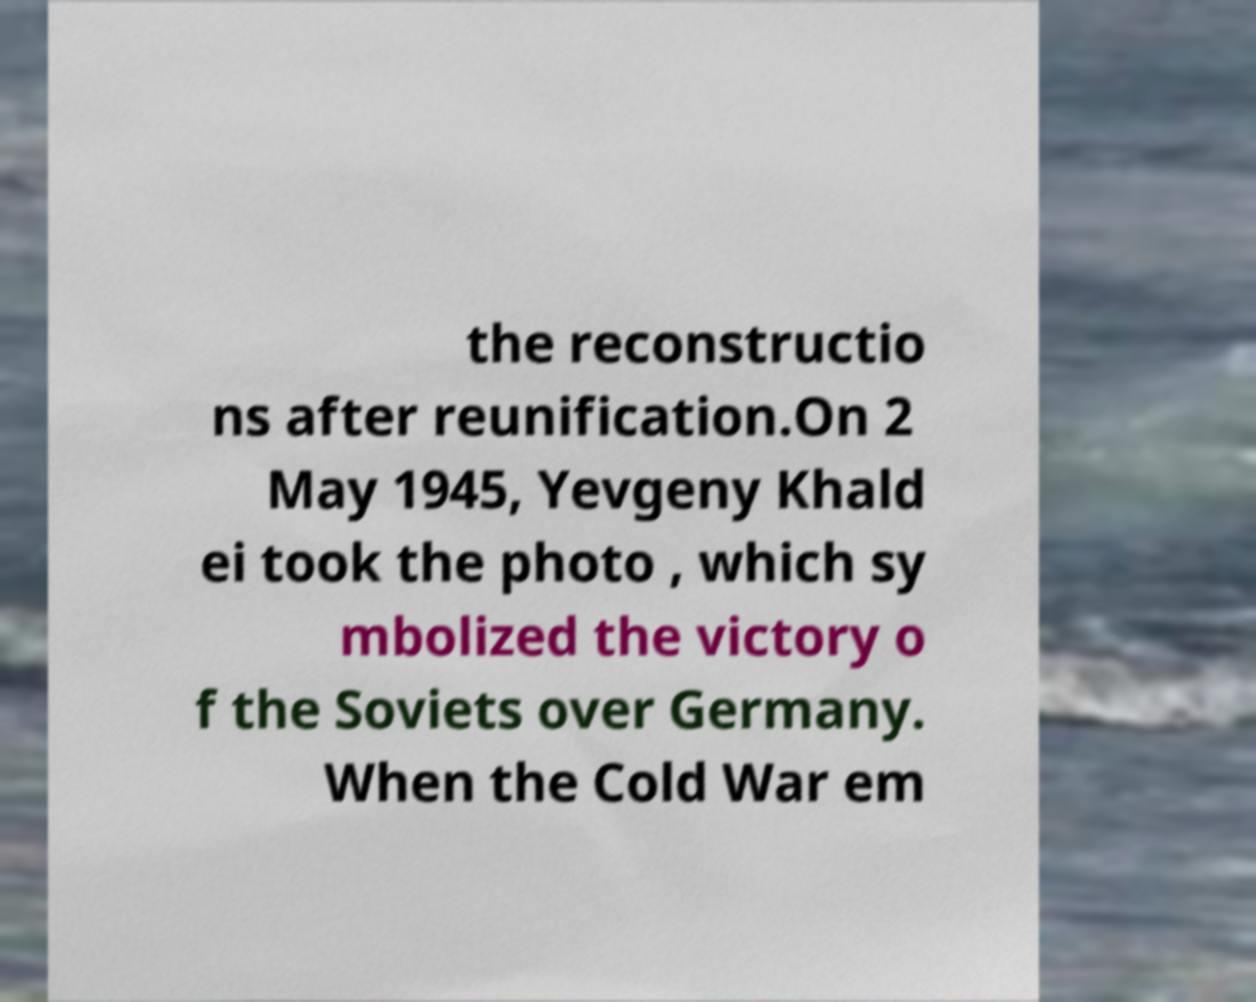There's text embedded in this image that I need extracted. Can you transcribe it verbatim? the reconstructio ns after reunification.On 2 May 1945, Yevgeny Khald ei took the photo , which sy mbolized the victory o f the Soviets over Germany. When the Cold War em 